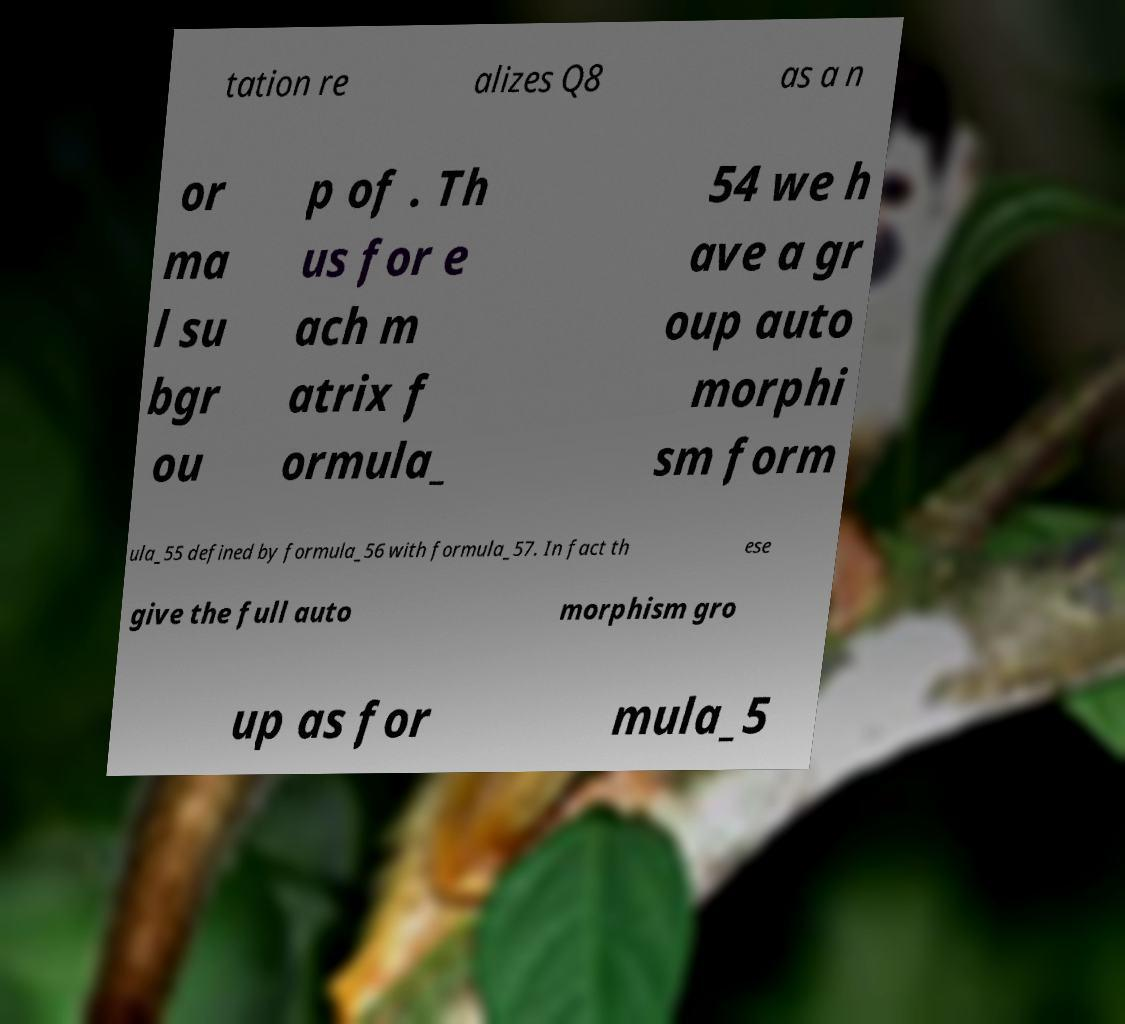Please identify and transcribe the text found in this image. tation re alizes Q8 as a n or ma l su bgr ou p of . Th us for e ach m atrix f ormula_ 54 we h ave a gr oup auto morphi sm form ula_55 defined by formula_56 with formula_57. In fact th ese give the full auto morphism gro up as for mula_5 